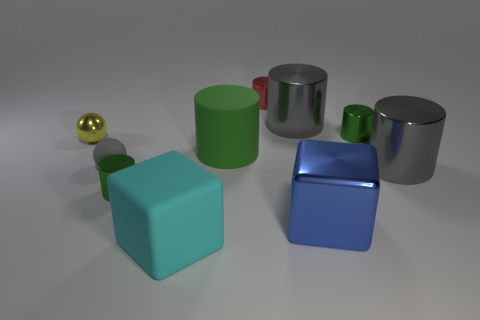Subtract all big metal cylinders. How many cylinders are left? 4 Subtract 2 spheres. How many spheres are left? 0 Subtract all gray spheres. How many spheres are left? 1 Subtract 2 gray cylinders. How many objects are left? 8 Subtract all cylinders. How many objects are left? 4 Subtract all gray spheres. Subtract all blue cubes. How many spheres are left? 1 Subtract all brown cubes. How many cyan cylinders are left? 0 Subtract all small yellow metal spheres. Subtract all big blue cubes. How many objects are left? 8 Add 8 big rubber cylinders. How many big rubber cylinders are left? 9 Add 2 matte balls. How many matte balls exist? 3 